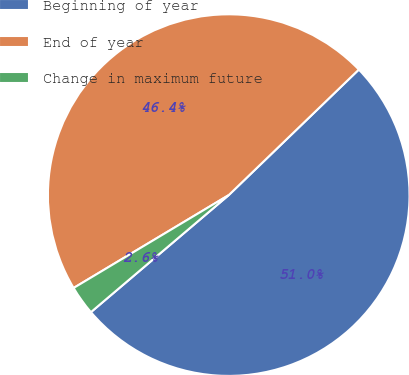Convert chart. <chart><loc_0><loc_0><loc_500><loc_500><pie_chart><fcel>Beginning of year<fcel>End of year<fcel>Change in maximum future<nl><fcel>51.01%<fcel>46.37%<fcel>2.62%<nl></chart> 